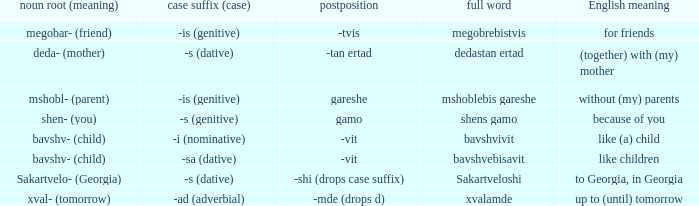When the whole expression is "shens gamo," what is its meaning in english? Because of you. 